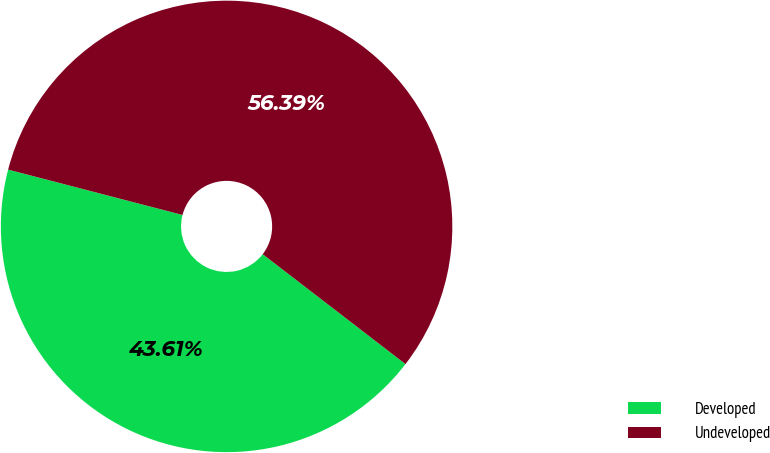Convert chart to OTSL. <chart><loc_0><loc_0><loc_500><loc_500><pie_chart><fcel>Developed<fcel>Undeveloped<nl><fcel>43.61%<fcel>56.39%<nl></chart> 